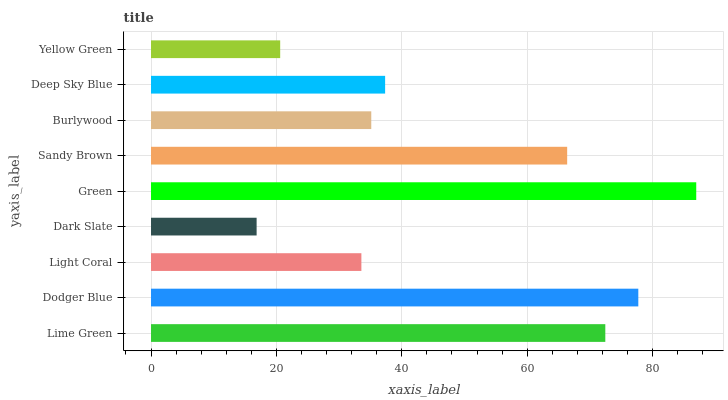Is Dark Slate the minimum?
Answer yes or no. Yes. Is Green the maximum?
Answer yes or no. Yes. Is Dodger Blue the minimum?
Answer yes or no. No. Is Dodger Blue the maximum?
Answer yes or no. No. Is Dodger Blue greater than Lime Green?
Answer yes or no. Yes. Is Lime Green less than Dodger Blue?
Answer yes or no. Yes. Is Lime Green greater than Dodger Blue?
Answer yes or no. No. Is Dodger Blue less than Lime Green?
Answer yes or no. No. Is Deep Sky Blue the high median?
Answer yes or no. Yes. Is Deep Sky Blue the low median?
Answer yes or no. Yes. Is Dodger Blue the high median?
Answer yes or no. No. Is Green the low median?
Answer yes or no. No. 